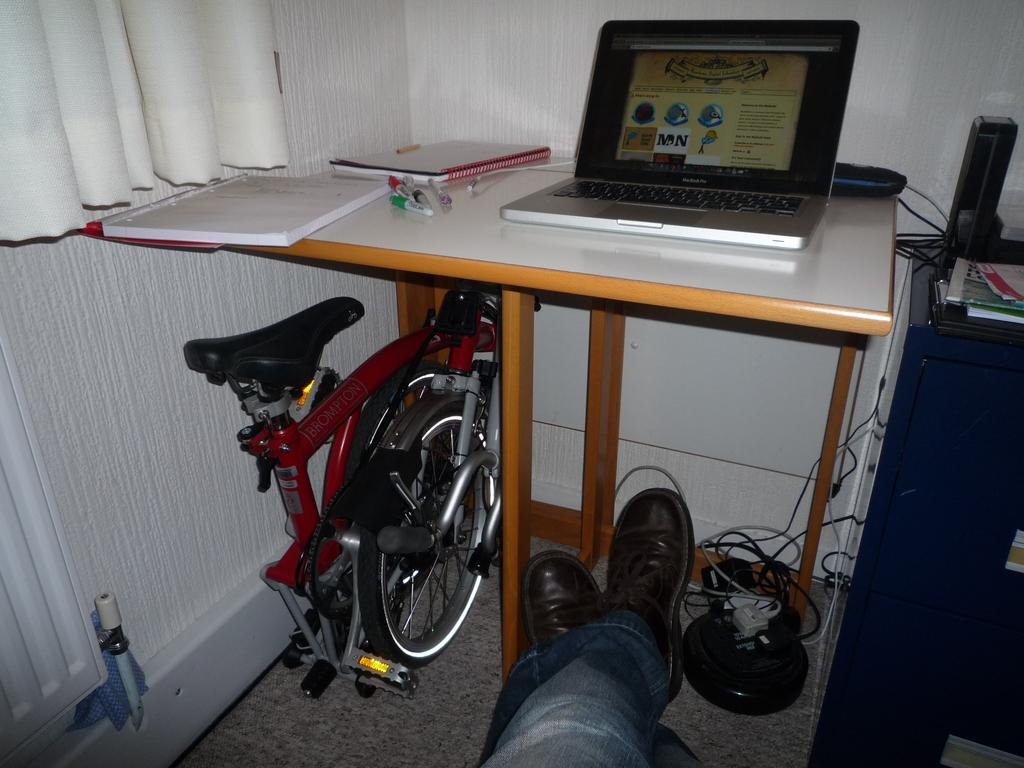What body part is visible in the image? There are person's legs in the image. What piece of furniture is present in the image? There is a table in the image. What items can be seen on the table? There are books, pens, and a laptop on the table. Are there any visible cords or wires in the image? Yes, there are wires visible in the image. What type of window treatment is present in the image? There is a curtain in the image. What color are the person's eyes in the image? There are no visible eyes in the image, as only the person's legs are shown. 